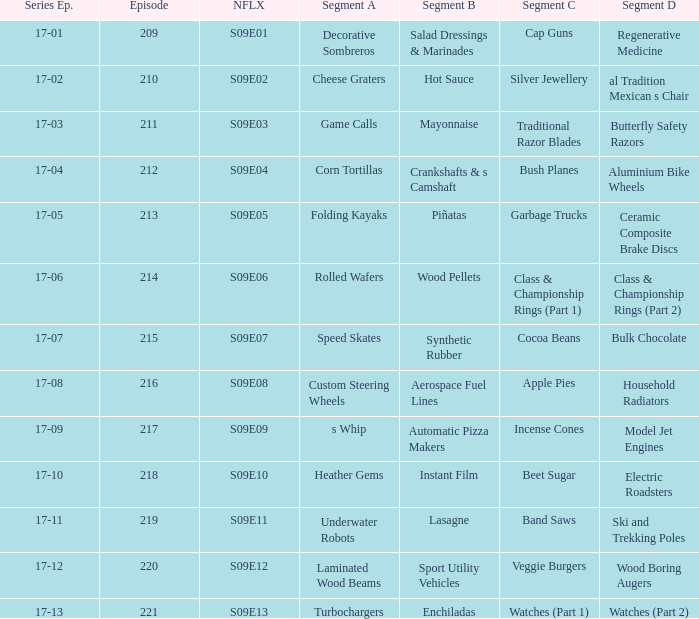Segment B of aerospace fuel lines has what segment A? Custom Steering Wheels. 